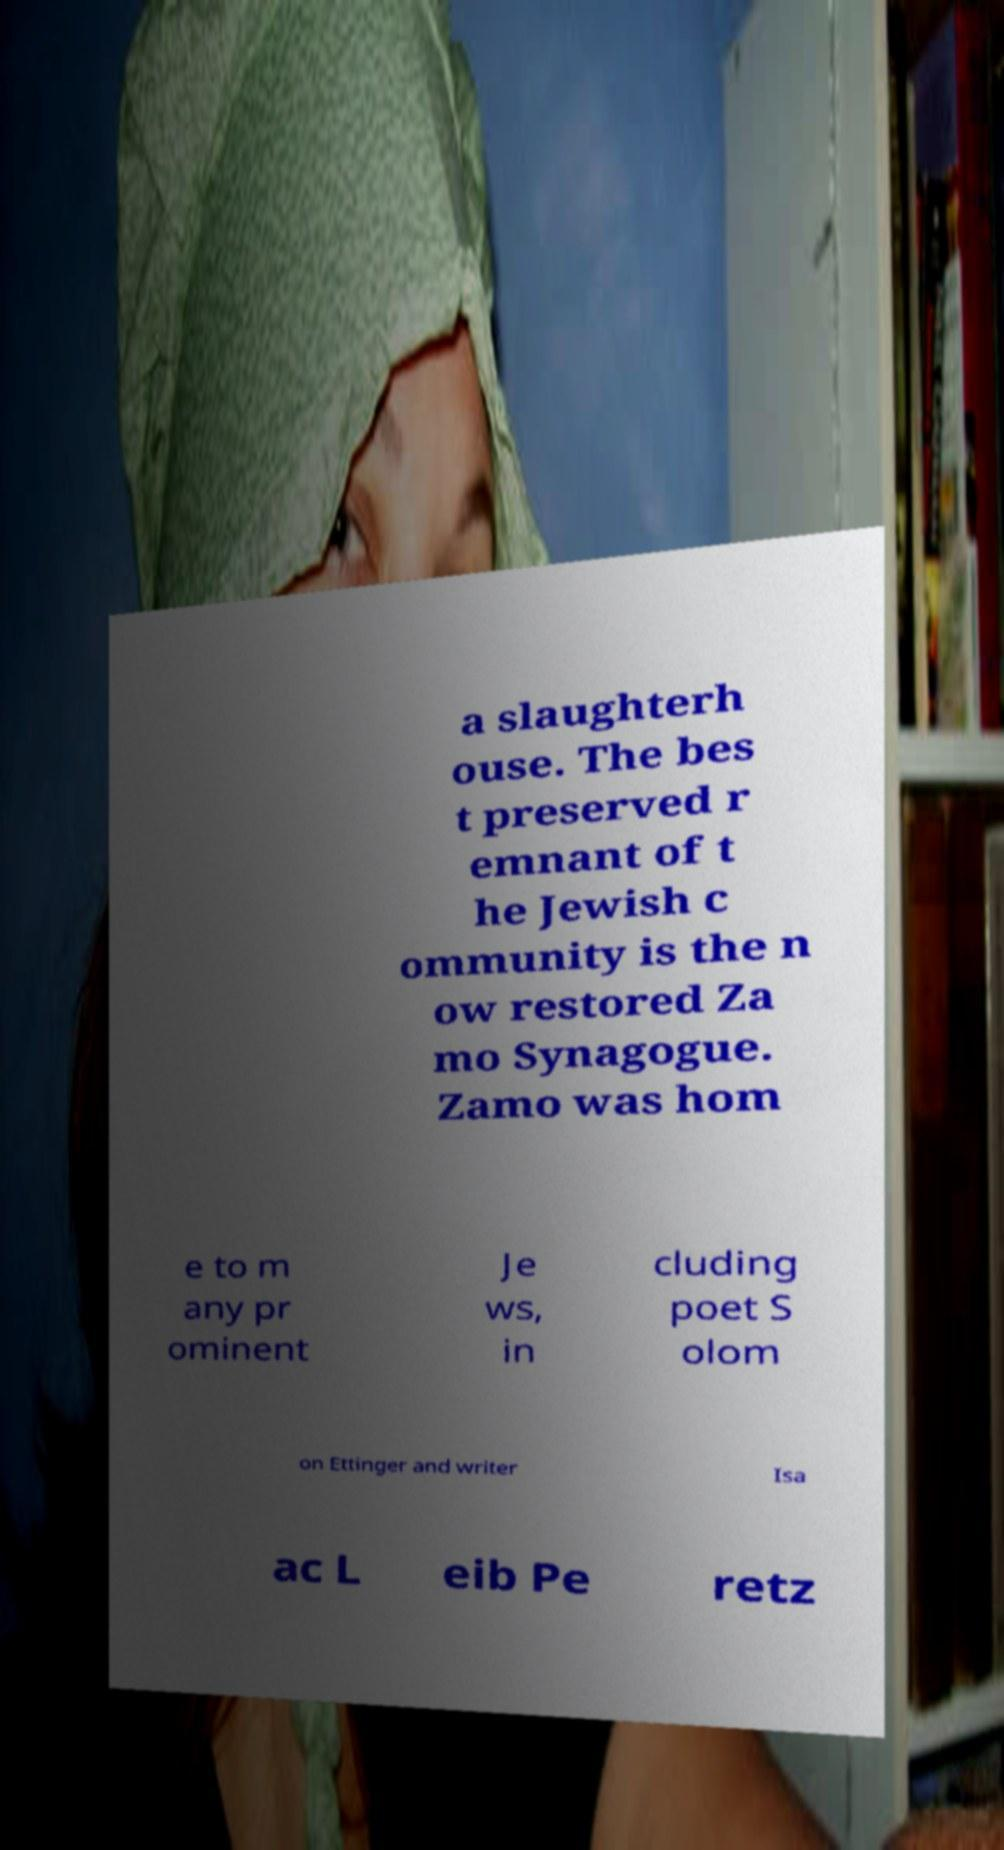I need the written content from this picture converted into text. Can you do that? a slaughterh ouse. The bes t preserved r emnant of t he Jewish c ommunity is the n ow restored Za mo Synagogue. Zamo was hom e to m any pr ominent Je ws, in cluding poet S olom on Ettinger and writer Isa ac L eib Pe retz 